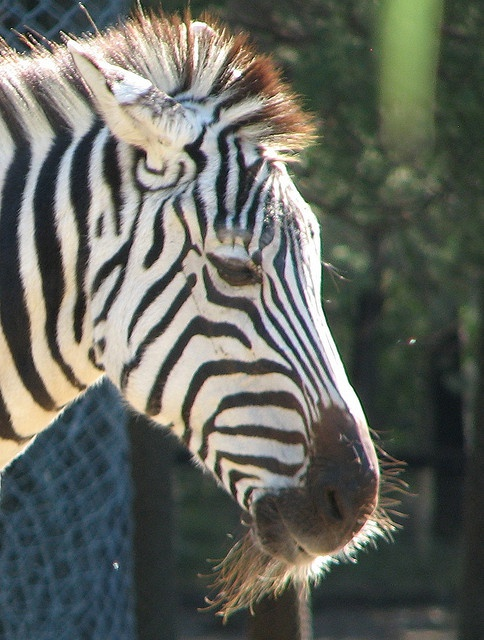Describe the objects in this image and their specific colors. I can see a zebra in purple, lightgray, black, darkgray, and gray tones in this image. 